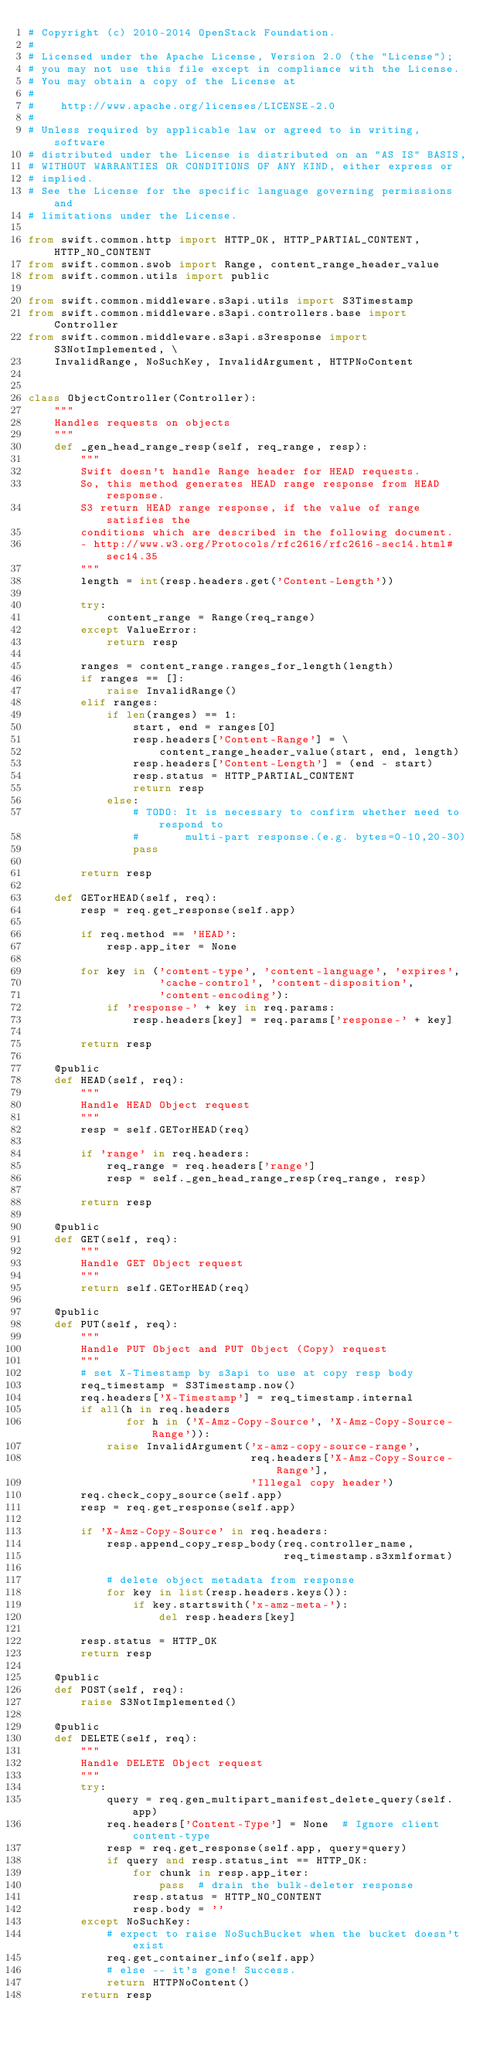Convert code to text. <code><loc_0><loc_0><loc_500><loc_500><_Python_># Copyright (c) 2010-2014 OpenStack Foundation.
#
# Licensed under the Apache License, Version 2.0 (the "License");
# you may not use this file except in compliance with the License.
# You may obtain a copy of the License at
#
#    http://www.apache.org/licenses/LICENSE-2.0
#
# Unless required by applicable law or agreed to in writing, software
# distributed under the License is distributed on an "AS IS" BASIS,
# WITHOUT WARRANTIES OR CONDITIONS OF ANY KIND, either express or
# implied.
# See the License for the specific language governing permissions and
# limitations under the License.

from swift.common.http import HTTP_OK, HTTP_PARTIAL_CONTENT, HTTP_NO_CONTENT
from swift.common.swob import Range, content_range_header_value
from swift.common.utils import public

from swift.common.middleware.s3api.utils import S3Timestamp
from swift.common.middleware.s3api.controllers.base import Controller
from swift.common.middleware.s3api.s3response import S3NotImplemented, \
    InvalidRange, NoSuchKey, InvalidArgument, HTTPNoContent


class ObjectController(Controller):
    """
    Handles requests on objects
    """
    def _gen_head_range_resp(self, req_range, resp):
        """
        Swift doesn't handle Range header for HEAD requests.
        So, this method generates HEAD range response from HEAD response.
        S3 return HEAD range response, if the value of range satisfies the
        conditions which are described in the following document.
        - http://www.w3.org/Protocols/rfc2616/rfc2616-sec14.html#sec14.35
        """
        length = int(resp.headers.get('Content-Length'))

        try:
            content_range = Range(req_range)
        except ValueError:
            return resp

        ranges = content_range.ranges_for_length(length)
        if ranges == []:
            raise InvalidRange()
        elif ranges:
            if len(ranges) == 1:
                start, end = ranges[0]
                resp.headers['Content-Range'] = \
                    content_range_header_value(start, end, length)
                resp.headers['Content-Length'] = (end - start)
                resp.status = HTTP_PARTIAL_CONTENT
                return resp
            else:
                # TODO: It is necessary to confirm whether need to respond to
                #       multi-part response.(e.g. bytes=0-10,20-30)
                pass

        return resp

    def GETorHEAD(self, req):
        resp = req.get_response(self.app)

        if req.method == 'HEAD':
            resp.app_iter = None

        for key in ('content-type', 'content-language', 'expires',
                    'cache-control', 'content-disposition',
                    'content-encoding'):
            if 'response-' + key in req.params:
                resp.headers[key] = req.params['response-' + key]

        return resp

    @public
    def HEAD(self, req):
        """
        Handle HEAD Object request
        """
        resp = self.GETorHEAD(req)

        if 'range' in req.headers:
            req_range = req.headers['range']
            resp = self._gen_head_range_resp(req_range, resp)

        return resp

    @public
    def GET(self, req):
        """
        Handle GET Object request
        """
        return self.GETorHEAD(req)

    @public
    def PUT(self, req):
        """
        Handle PUT Object and PUT Object (Copy) request
        """
        # set X-Timestamp by s3api to use at copy resp body
        req_timestamp = S3Timestamp.now()
        req.headers['X-Timestamp'] = req_timestamp.internal
        if all(h in req.headers
               for h in ('X-Amz-Copy-Source', 'X-Amz-Copy-Source-Range')):
            raise InvalidArgument('x-amz-copy-source-range',
                                  req.headers['X-Amz-Copy-Source-Range'],
                                  'Illegal copy header')
        req.check_copy_source(self.app)
        resp = req.get_response(self.app)

        if 'X-Amz-Copy-Source' in req.headers:
            resp.append_copy_resp_body(req.controller_name,
                                       req_timestamp.s3xmlformat)

            # delete object metadata from response
            for key in list(resp.headers.keys()):
                if key.startswith('x-amz-meta-'):
                    del resp.headers[key]

        resp.status = HTTP_OK
        return resp

    @public
    def POST(self, req):
        raise S3NotImplemented()

    @public
    def DELETE(self, req):
        """
        Handle DELETE Object request
        """
        try:
            query = req.gen_multipart_manifest_delete_query(self.app)
            req.headers['Content-Type'] = None  # Ignore client content-type
            resp = req.get_response(self.app, query=query)
            if query and resp.status_int == HTTP_OK:
                for chunk in resp.app_iter:
                    pass  # drain the bulk-deleter response
                resp.status = HTTP_NO_CONTENT
                resp.body = ''
        except NoSuchKey:
            # expect to raise NoSuchBucket when the bucket doesn't exist
            req.get_container_info(self.app)
            # else -- it's gone! Success.
            return HTTPNoContent()
        return resp
</code> 